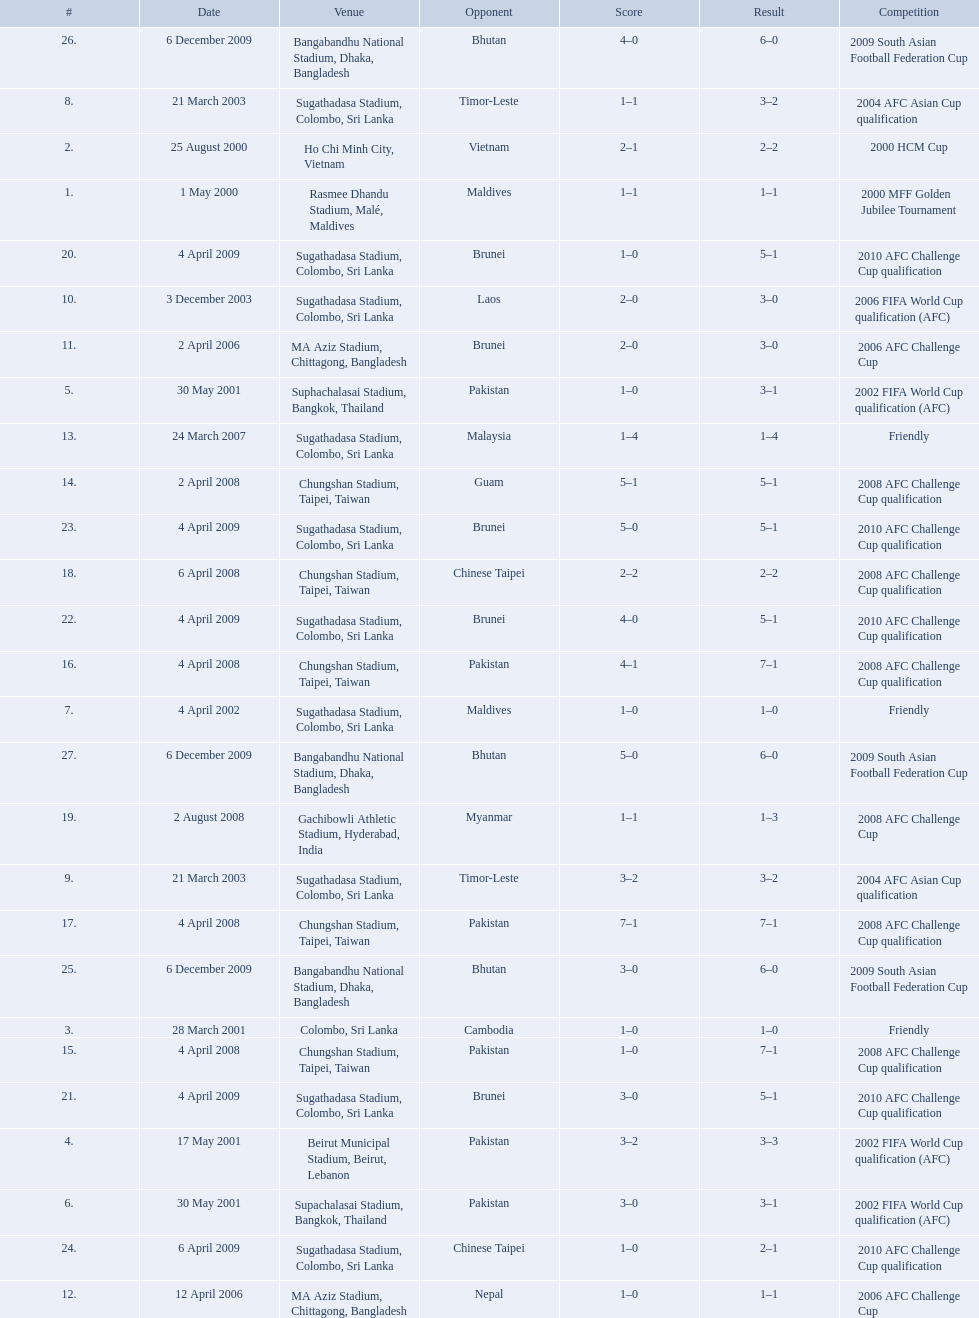How many venues are in the table? 27. Which one is the top listed? Rasmee Dhandu Stadium, Malé, Maldives. What are the venues Rasmee Dhandu Stadium, Malé, Maldives, Ho Chi Minh City, Vietnam, Colombo, Sri Lanka, Beirut Municipal Stadium, Beirut, Lebanon, Suphachalasai Stadium, Bangkok, Thailand, Supachalasai Stadium, Bangkok, Thailand, Sugathadasa Stadium, Colombo, Sri Lanka, Sugathadasa Stadium, Colombo, Sri Lanka, Sugathadasa Stadium, Colombo, Sri Lanka, Sugathadasa Stadium, Colombo, Sri Lanka, MA Aziz Stadium, Chittagong, Bangladesh, MA Aziz Stadium, Chittagong, Bangladesh, Sugathadasa Stadium, Colombo, Sri Lanka, Chungshan Stadium, Taipei, Taiwan, Chungshan Stadium, Taipei, Taiwan, Chungshan Stadium, Taipei, Taiwan, Chungshan Stadium, Taipei, Taiwan, Chungshan Stadium, Taipei, Taiwan, Gachibowli Athletic Stadium, Hyderabad, India, Sugathadasa Stadium, Colombo, Sri Lanka, Sugathadasa Stadium, Colombo, Sri Lanka, Sugathadasa Stadium, Colombo, Sri Lanka, Sugathadasa Stadium, Colombo, Sri Lanka, Sugathadasa Stadium, Colombo, Sri Lanka, Bangabandhu National Stadium, Dhaka, Bangladesh, Bangabandhu National Stadium, Dhaka, Bangladesh, Bangabandhu National Stadium, Dhaka, Bangladesh. What are the #'s? 1., 2., 3., 4., 5., 6., 7., 8., 9., 10., 11., 12., 13., 14., 15., 16., 17., 18., 19., 20., 21., 22., 23., 24., 25., 26., 27. Which one is #1? Rasmee Dhandu Stadium, Malé, Maldives. 